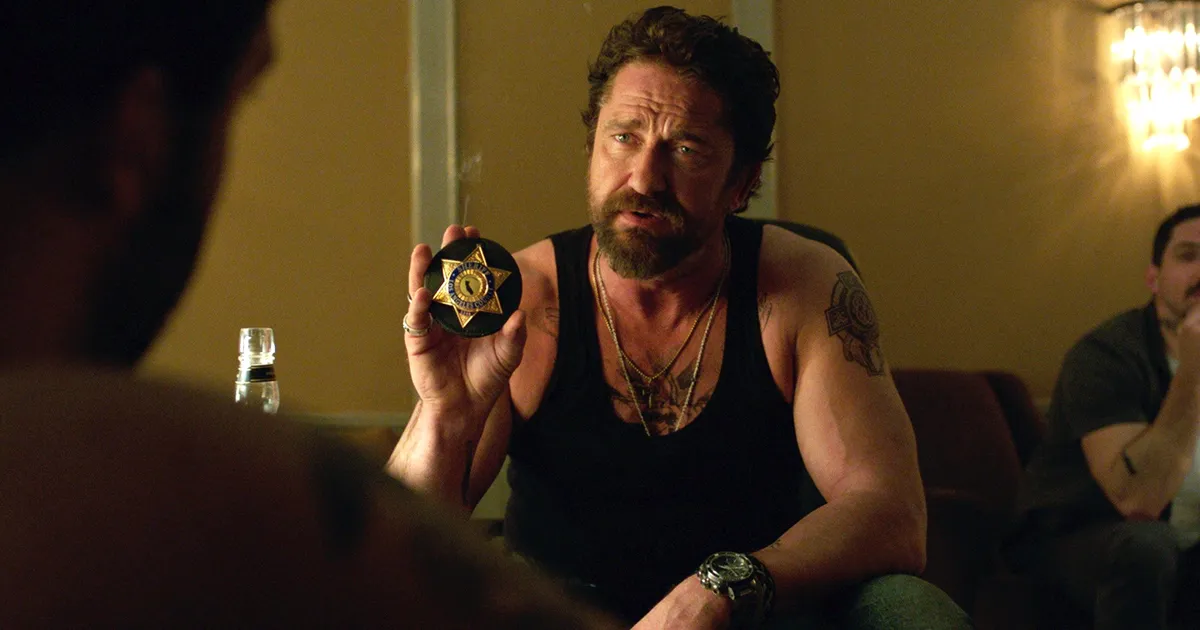Can you describe the atmosphere of the room and how it contributes to the scene? The room's atmosphere is dim and somber, with soft lighting from a chandelier and minimal decorative elements, which contributes to a tense and serious mood. The intimacy of the setting, combined with the somber tones, helps amplify the gravity of the dialogue or conflict occurring within the scene. Is there anything significant about the other people in the background? The individuals in the background, while less prominent, add depth to the scene. Their casual postures and engagement in mundane activities like sitting or standing near a table with a water bottle subtly contrast with the intensity of the main character, possibly highlighting a backdrop of normalcy against which more dramatic or pivotal events are unfolding. 